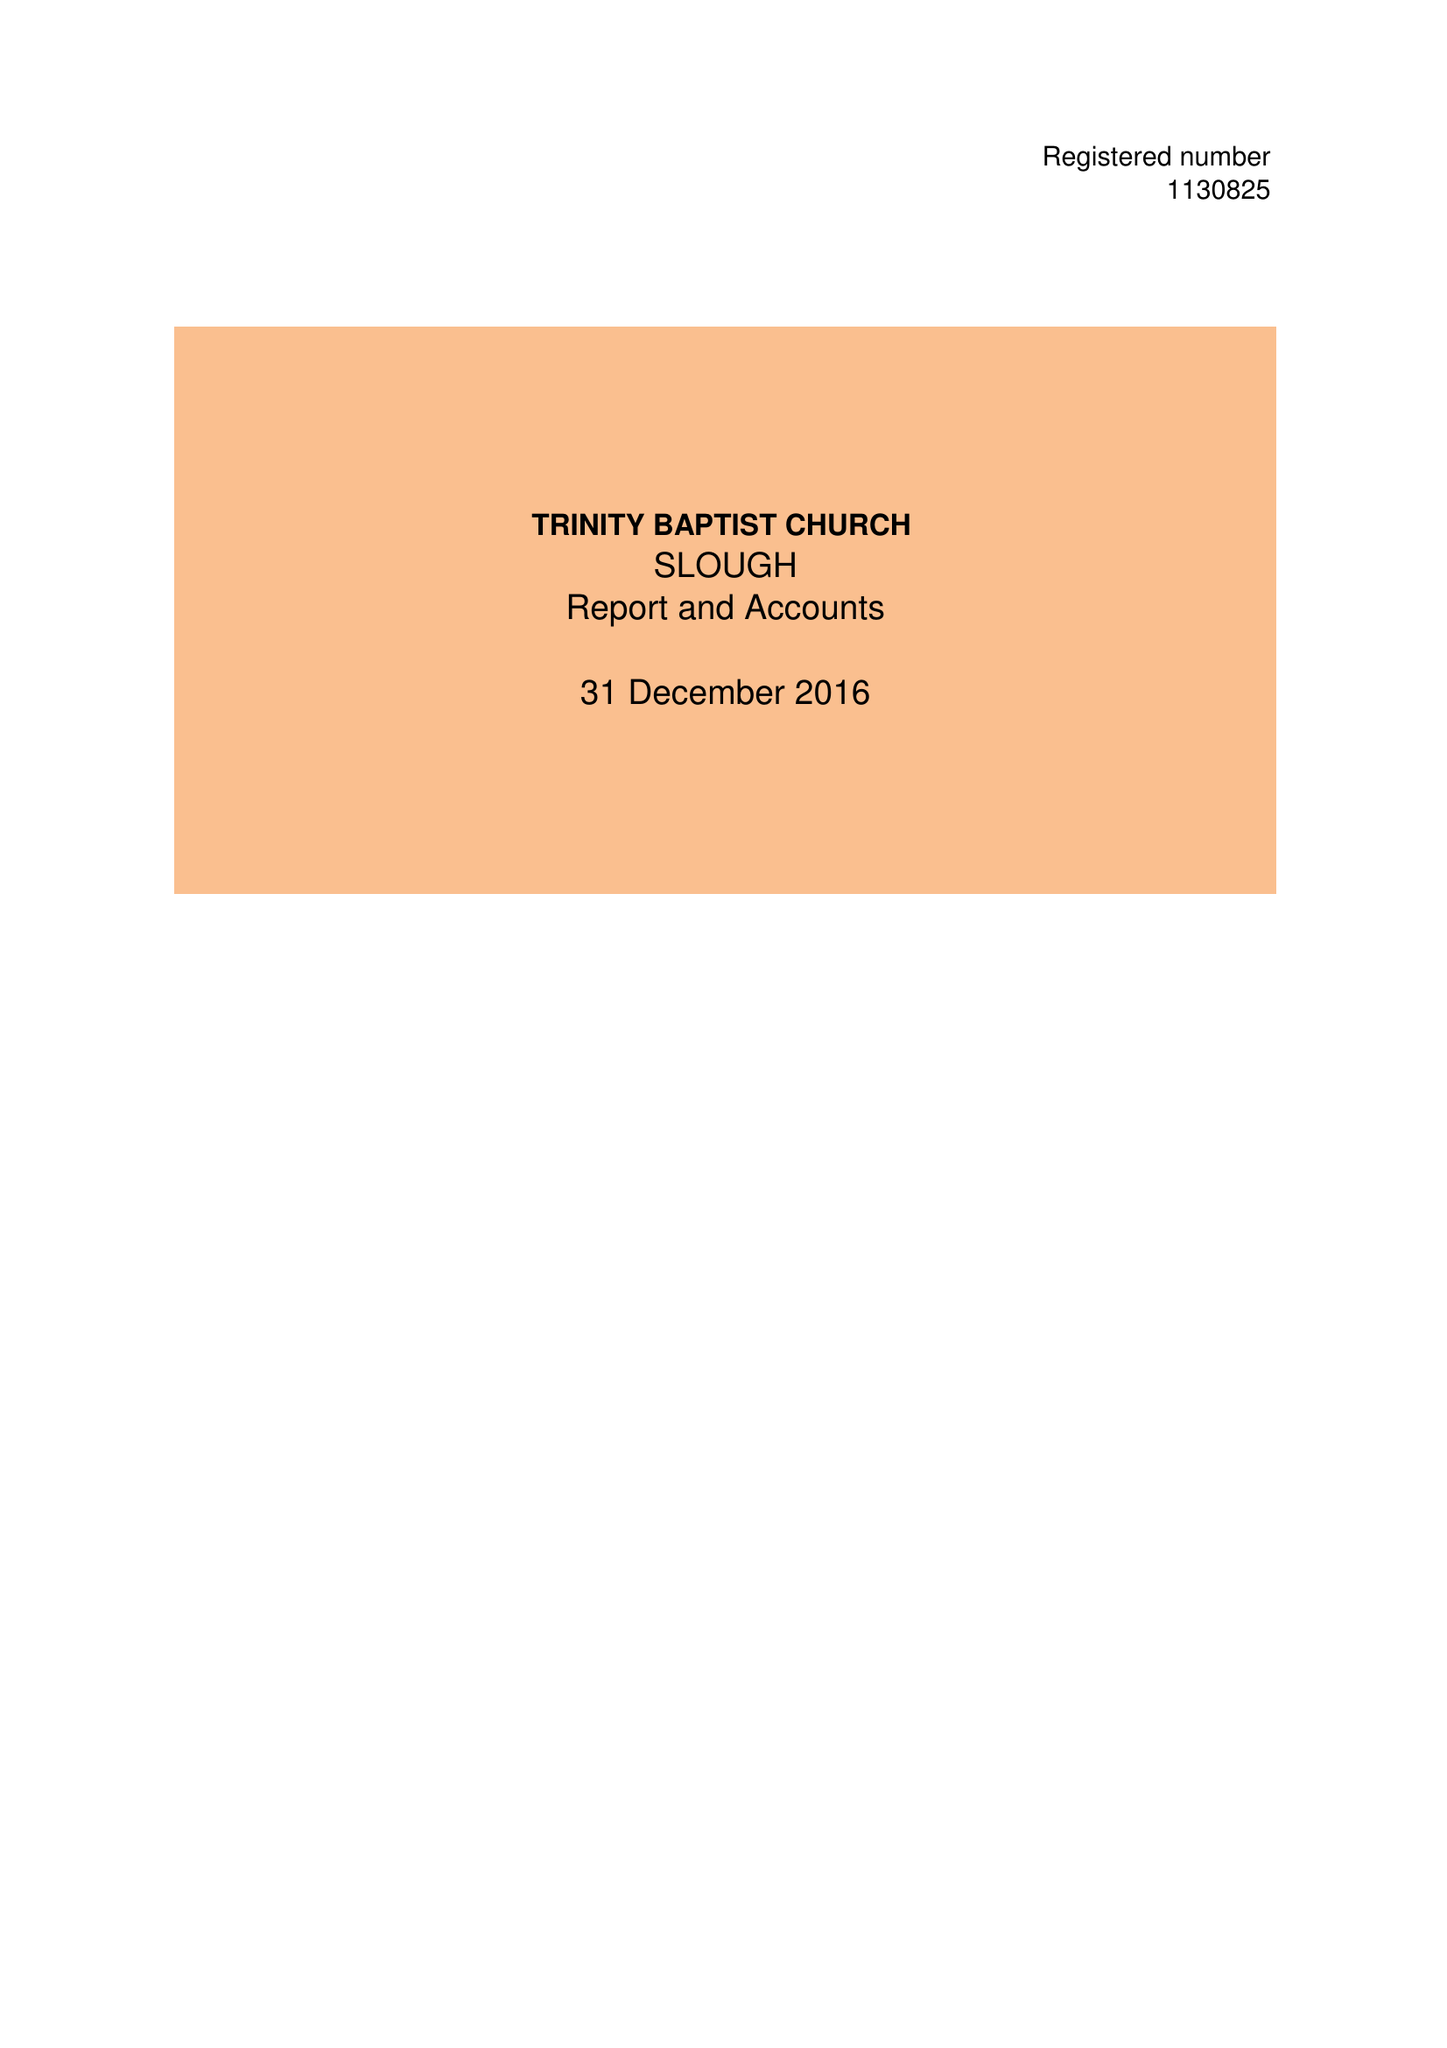What is the value for the report_date?
Answer the question using a single word or phrase. 2016-12-31 